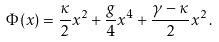Convert formula to latex. <formula><loc_0><loc_0><loc_500><loc_500>\Phi ( x ) = \frac { \kappa } { 2 } x ^ { 2 } + \frac { g } { 4 } x ^ { 4 } + \frac { \gamma - \kappa } { 2 } x ^ { 2 } \, .</formula> 